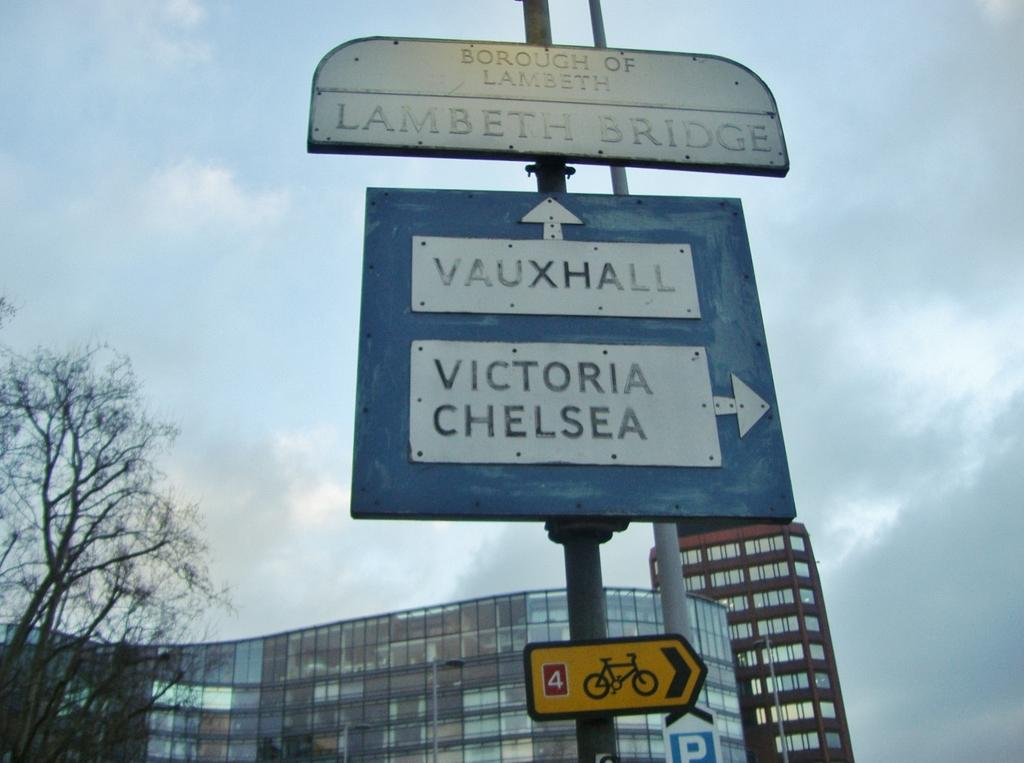<image>
Describe the image concisely. A sign that says Borough of Lamberth Lamberth Bridge. 